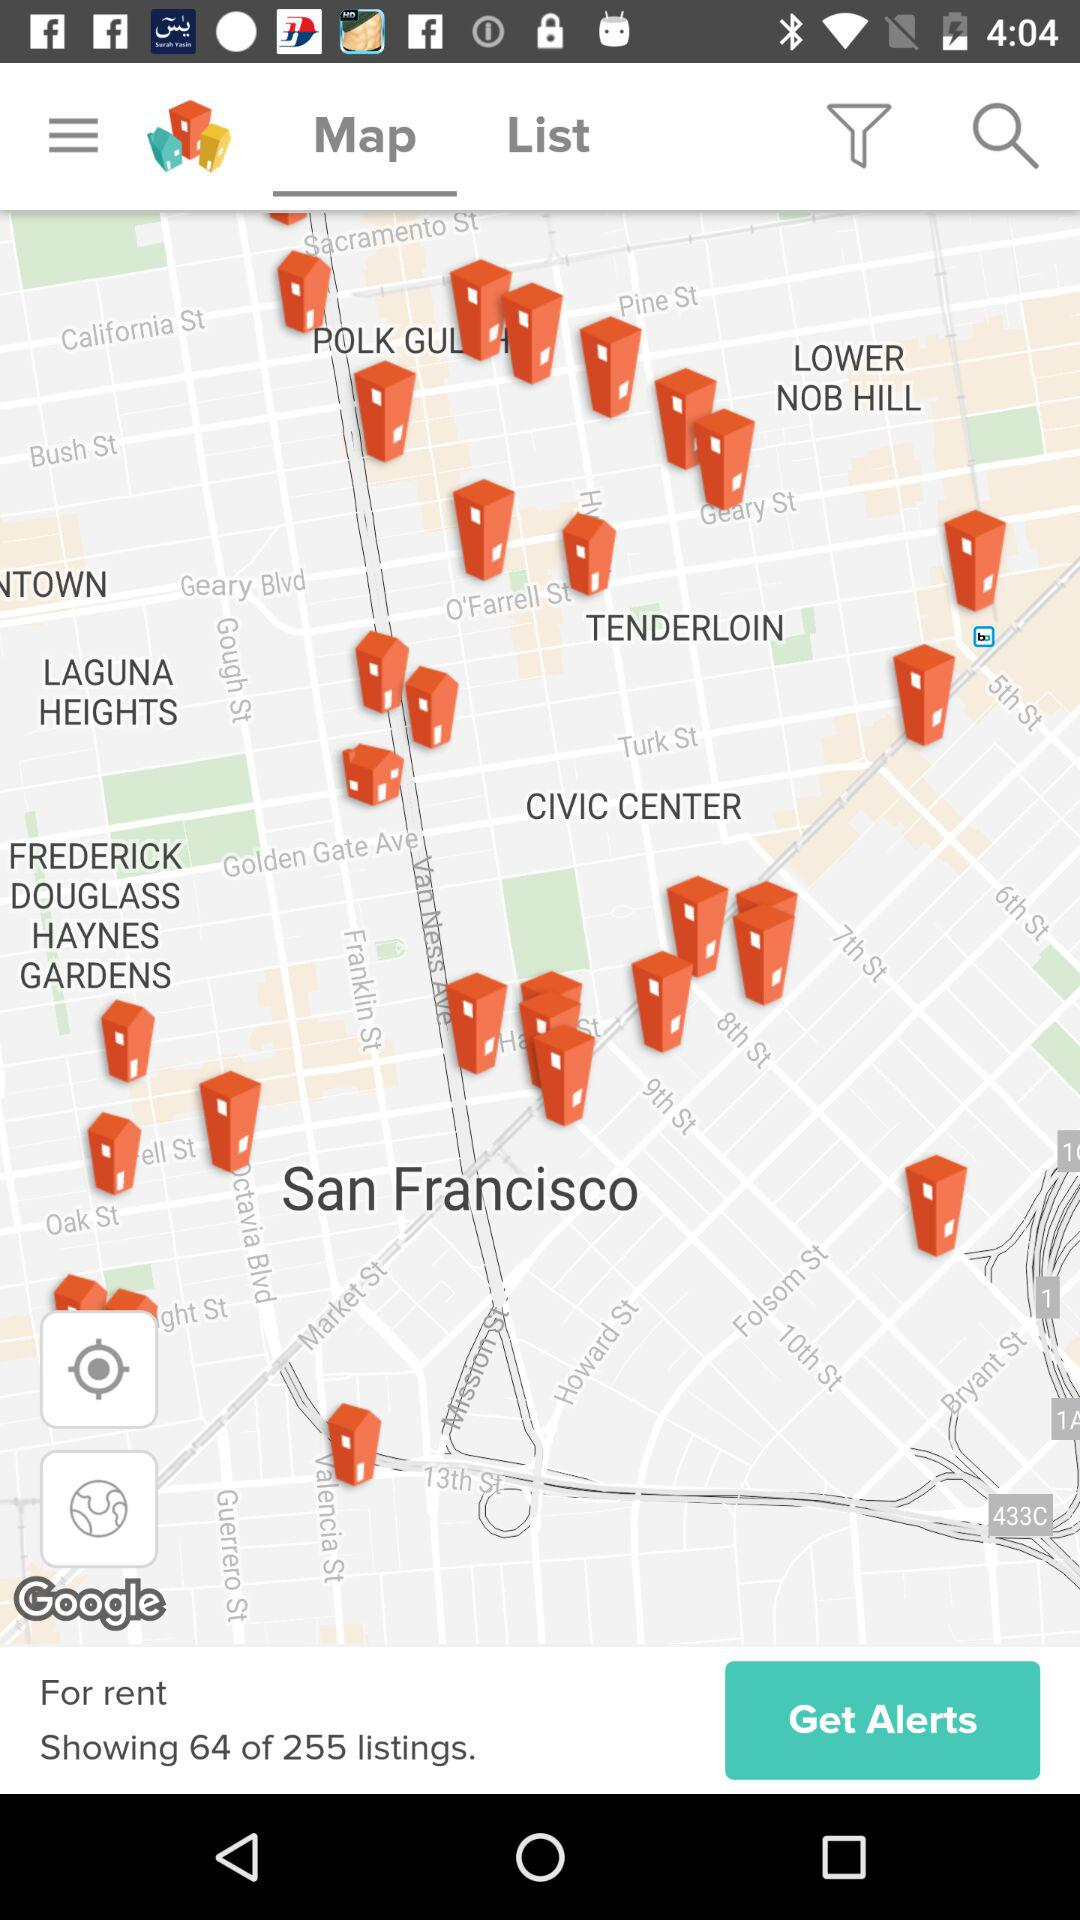What is the number of listings shown right now for rent? The number of listings shown right now is 64. 